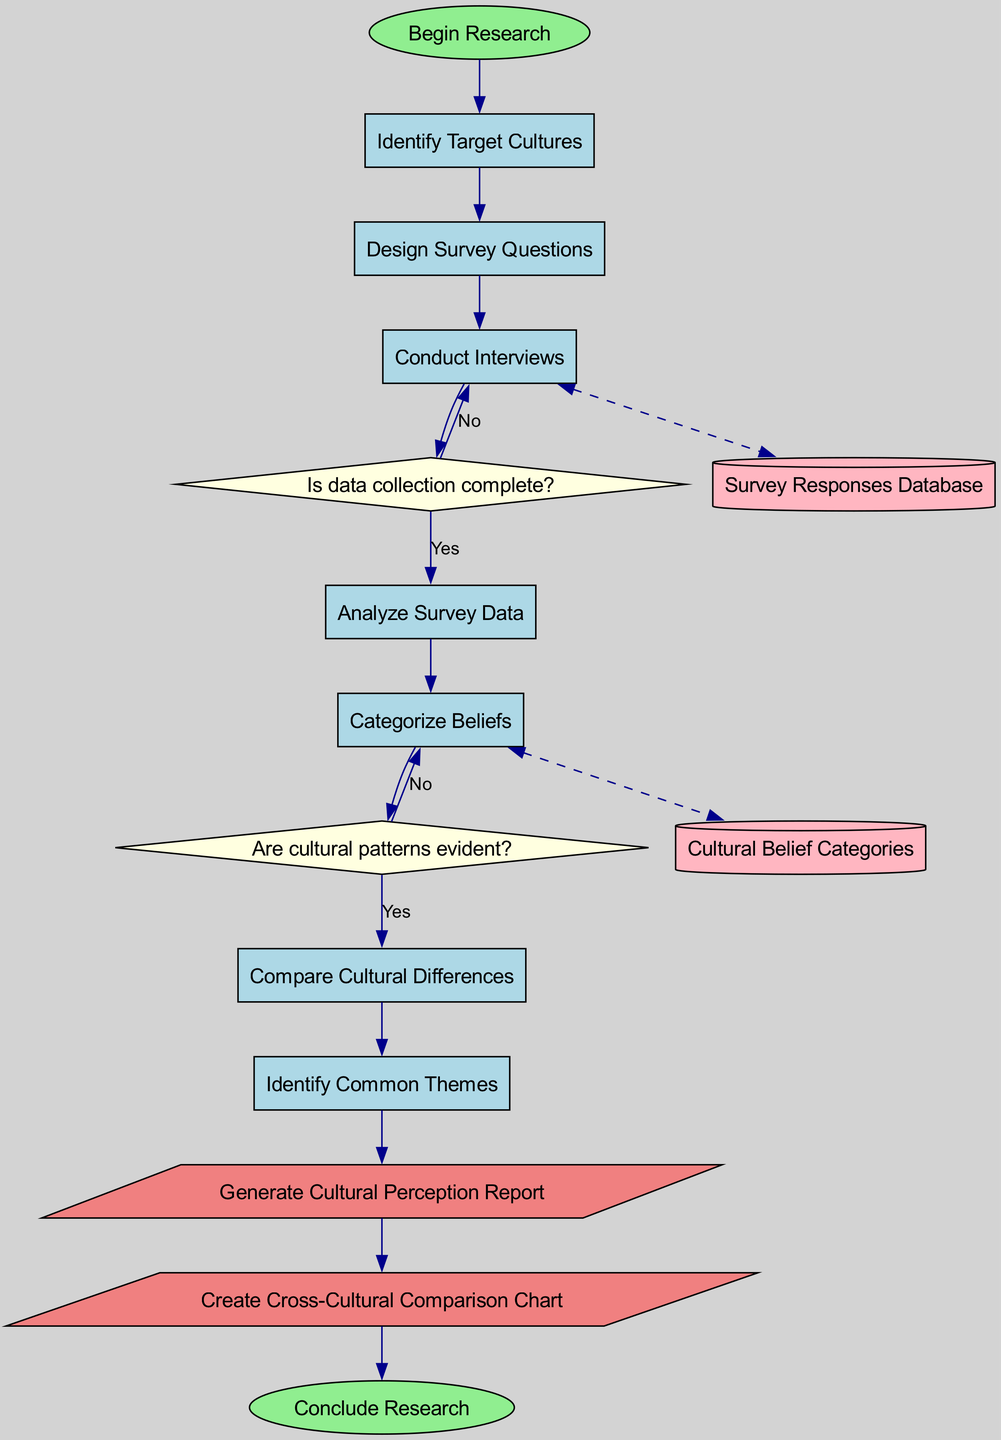What is the start node of the diagram? The start node, represented in the diagram, is labeled as "Begin Research." It is the first point in the workflow that initiates the research process.
Answer: Begin Research How many processes are in the workflow? There are seven processes listed in the workflow, each representing a distinct step in organizing cultural beliefs about homeopathy.
Answer: 7 What happens after conducting interviews if data collection is incomplete? If data collection is incomplete after conducting interviews, the flow indicates returning to the "Conduct Interviews" node, suggesting ongoing data collection until completeness is achieved.
Answer: Conduct Interviews What follows the analysis of survey data if cultural patterns are not evident? If cultural patterns are not evident after analyzing the survey data, the subsequent step is to "Categorize Beliefs," as indicated by the decision flow after the analysis process.
Answer: Categorize Beliefs Which data store is linked to the analysis of survey data? The data store linked to the analysis of survey data is the "Survey Responses Database." This connection reflects the storage of collected responses used for analysis.
Answer: Survey Responses Database Identify the final output of the workflow. The final output in the workflow is "Create Cross-Cultural Comparison Chart," which follows the generation of the cultural perception report as part of concluding the research work.
Answer: Create Cross-Cultural Comparison Chart What decision must be made after analyzing survey data? After analyzing survey data, the decision that must be made is whether data collection is complete, which leads to further actions based on the answer to that question.
Answer: Is data collection complete? How many edges connect the processes in the workflow? The number of edges connecting the processes in the workflow can be counted, and there are a total of nine edges shown, which represent the flow of steps through the workflow.
Answer: 9 What type of node is used for decision points in the diagram? The decision points in the diagram are represented by diamond-shaped nodes, which are a standard symbol for decisions in flowcharts, indicating a question to be answered.
Answer: Diamond 